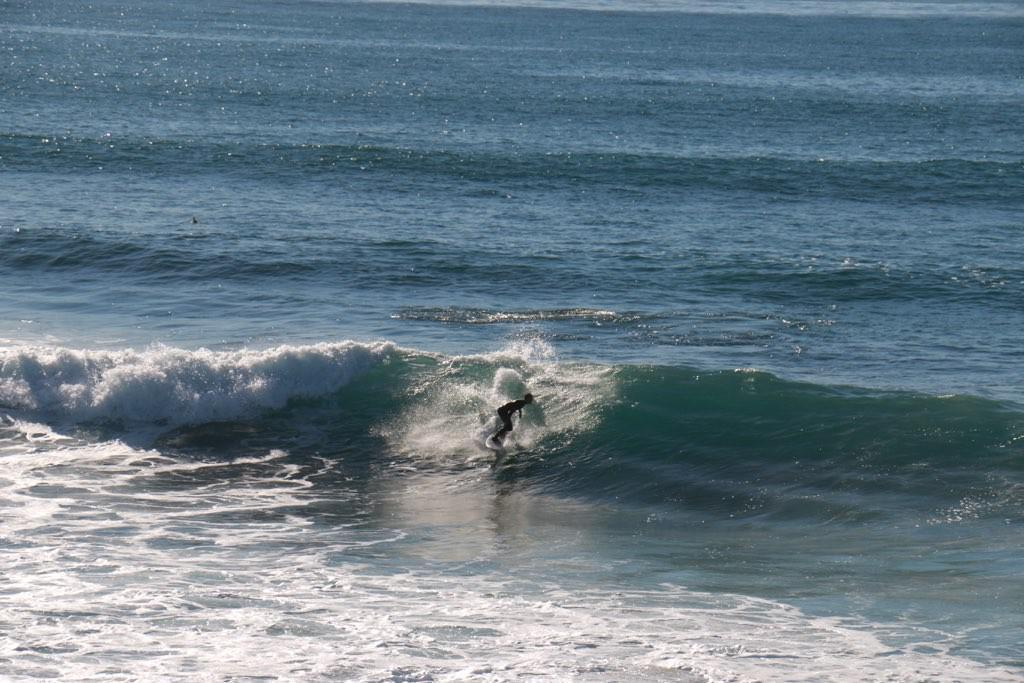What is visible in the image? There is water visible in the image. What activity is the person in the image engaged in? A person is surfing on a surfboard in the water. What type of milk can be seen in the image? There is no milk present in the image; it features water and a person surfing. What direction is the bun facing in the image? There is no bun present in the image. 